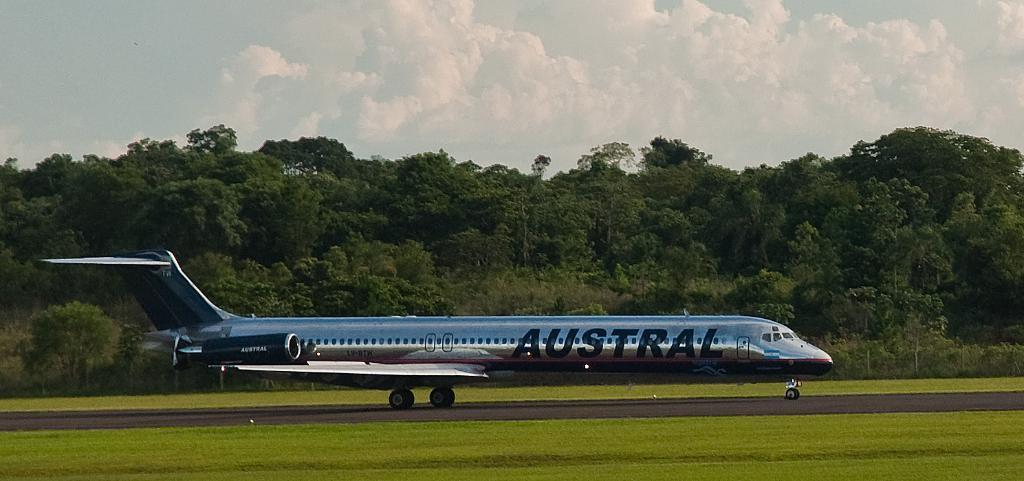<image>
Share a concise interpretation of the image provided. a plane with the word 'austral' written on the side of it 